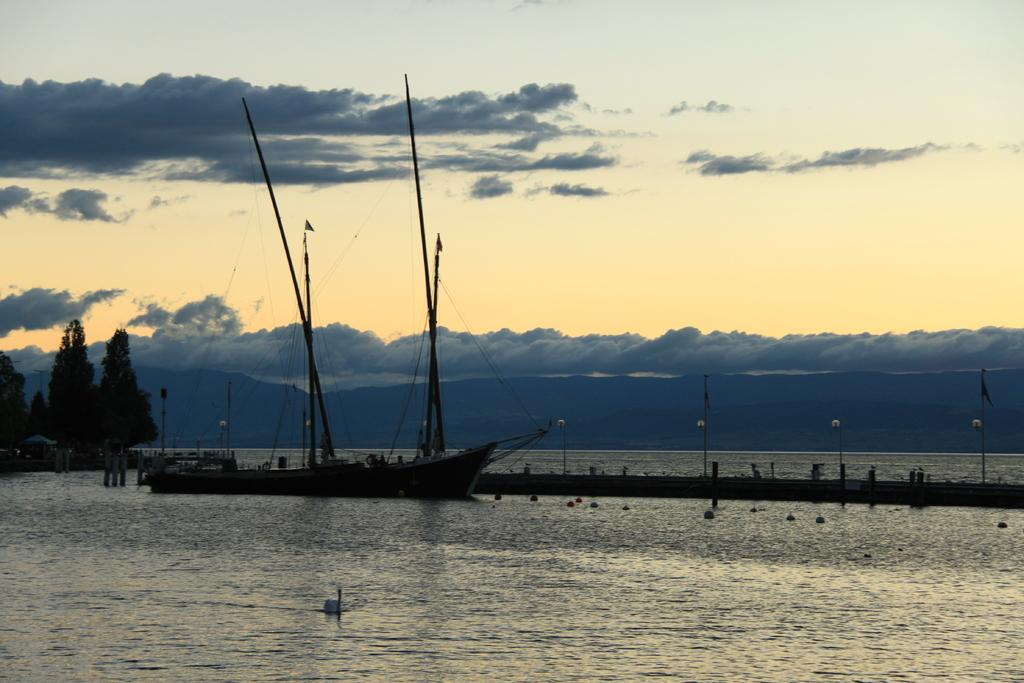What can be seen in the sky in the background of the image? There are clouds in the sky in the background of the image. What is the main subject in the image? There is a boat in the image. What are the poles used for in the image? The poles are likely used for supporting the flags in the image. What is the water in the image used for? The water is likely used for boating or other water-related activities. What objects are present in the image? There are flags and a swan visible in the image. Where is the desk located in the image? There is no desk present in the image. What type of wish can be granted by the swan in the image? The image does not depict a swan granting wishes; it is simply a swan visible in the image. 